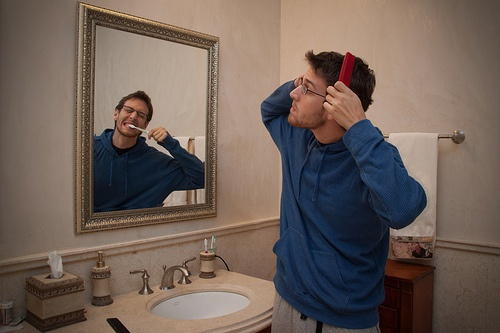Describe the objects in this image and their specific colors. I can see people in black, navy, brown, and gray tones, people in black, brown, maroon, and navy tones, sink in black, darkgray, and gray tones, and toothbrush in black, darkgray, gray, and lightgray tones in this image. 